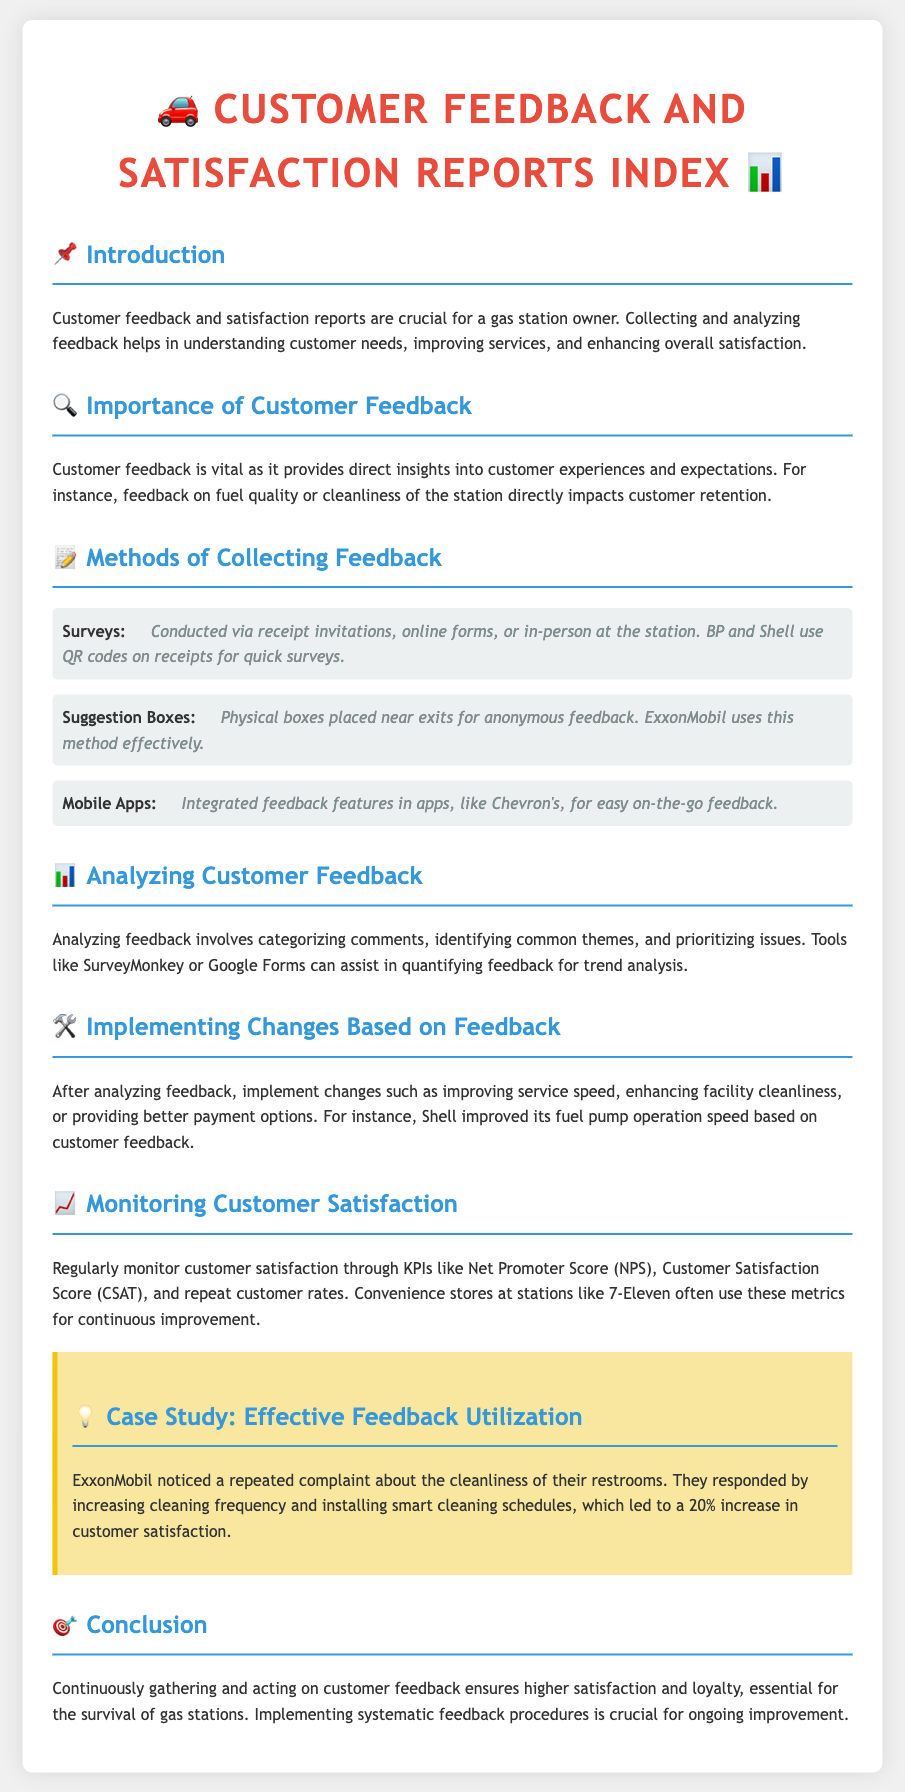What is the title of the document? The title is presented at the top of the document and summarizes the content focus.
Answer: Customer Feedback and Satisfaction Reports Index What method of feedback collection is mentioned first? This method is listed in the section detailing collection methods and is the first mentioned.
Answer: Surveys How did ExxonMobil respond to restroom cleanliness complaints? The case study illustrates how they reacted to improve customer feedback based on identified issues.
Answer: Increased cleaning frequency What is a KPI mentioned for monitoring customer satisfaction? This is in the section discussing metrics for regular monitoring of customer satisfaction levels.
Answer: Net Promoter Score How much did customer satisfaction increase after ExxonMobil's changes? The case study provides specific statistics concerning customer satisfaction improvement.
Answer: 20% 